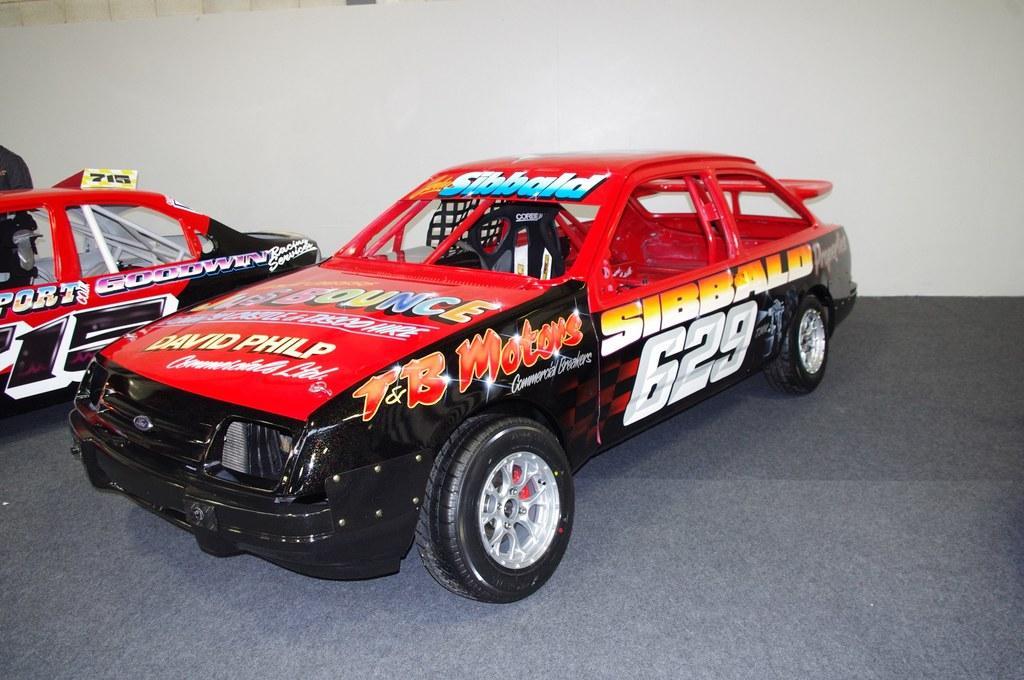Describe this image in one or two sentences. On the left of this picture we can see the two toy cars are placed on an object and we can see the text on the cars and we can see the numbers on the car. In the background we can see a white color object and we can see some other objects. 